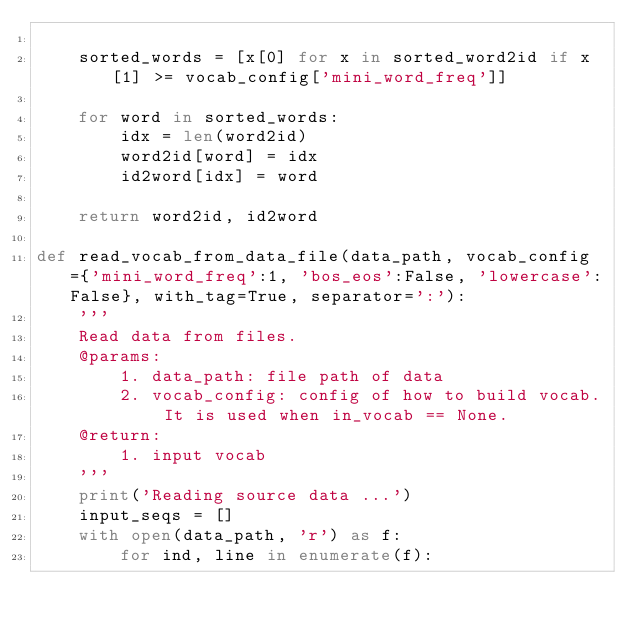Convert code to text. <code><loc_0><loc_0><loc_500><loc_500><_Python_>
    sorted_words = [x[0] for x in sorted_word2id if x[1] >= vocab_config['mini_word_freq']]
    
    for word in sorted_words:
        idx = len(word2id)
        word2id[word] = idx
        id2word[idx] = word

    return word2id, id2word

def read_vocab_from_data_file(data_path, vocab_config={'mini_word_freq':1, 'bos_eos':False, 'lowercase':False}, with_tag=True, separator=':'):
    '''
    Read data from files.
    @params:
        1. data_path: file path of data
        2. vocab_config: config of how to build vocab. It is used when in_vocab == None.
    @return:
        1. input vocab
    '''
    print('Reading source data ...')
    input_seqs = []
    with open(data_path, 'r') as f:
        for ind, line in enumerate(f):</code> 